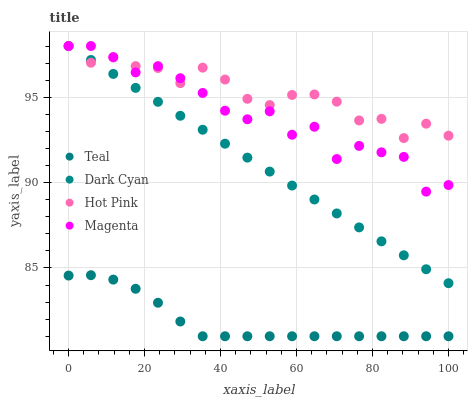Does Teal have the minimum area under the curve?
Answer yes or no. Yes. Does Hot Pink have the maximum area under the curve?
Answer yes or no. Yes. Does Magenta have the minimum area under the curve?
Answer yes or no. No. Does Magenta have the maximum area under the curve?
Answer yes or no. No. Is Dark Cyan the smoothest?
Answer yes or no. Yes. Is Magenta the roughest?
Answer yes or no. Yes. Is Hot Pink the smoothest?
Answer yes or no. No. Is Hot Pink the roughest?
Answer yes or no. No. Does Teal have the lowest value?
Answer yes or no. Yes. Does Magenta have the lowest value?
Answer yes or no. No. Does Hot Pink have the highest value?
Answer yes or no. Yes. Does Teal have the highest value?
Answer yes or no. No. Is Teal less than Hot Pink?
Answer yes or no. Yes. Is Hot Pink greater than Teal?
Answer yes or no. Yes. Does Magenta intersect Dark Cyan?
Answer yes or no. Yes. Is Magenta less than Dark Cyan?
Answer yes or no. No. Is Magenta greater than Dark Cyan?
Answer yes or no. No. Does Teal intersect Hot Pink?
Answer yes or no. No. 